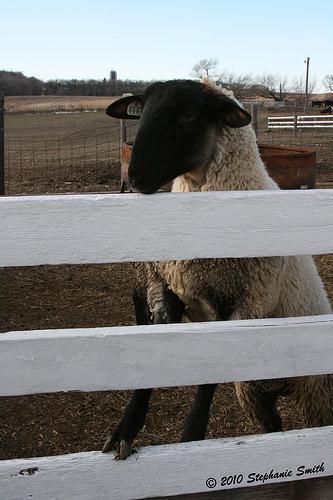How many sheep are in this picture?
Give a very brief answer. 1. 